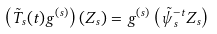<formula> <loc_0><loc_0><loc_500><loc_500>\left ( \tilde { T } _ { s } ( t ) g ^ { ( s ) } \right ) ( Z _ { s } ) = g ^ { ( s ) } \left ( \tilde { \psi } _ { s } ^ { - t } Z _ { s } \right )</formula> 